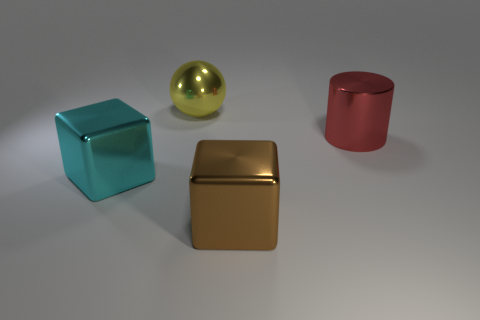What kind of materials do the objects seem to be made of? The objects appear to be made of different materials. The turquoise cube and red cylinder have a matte finish, suggesting a plastic or painted metal surface. Meanwhile, the gold sphere and cube have a highly reflective surface, indicative of polished metal or a similarly reflective material. 